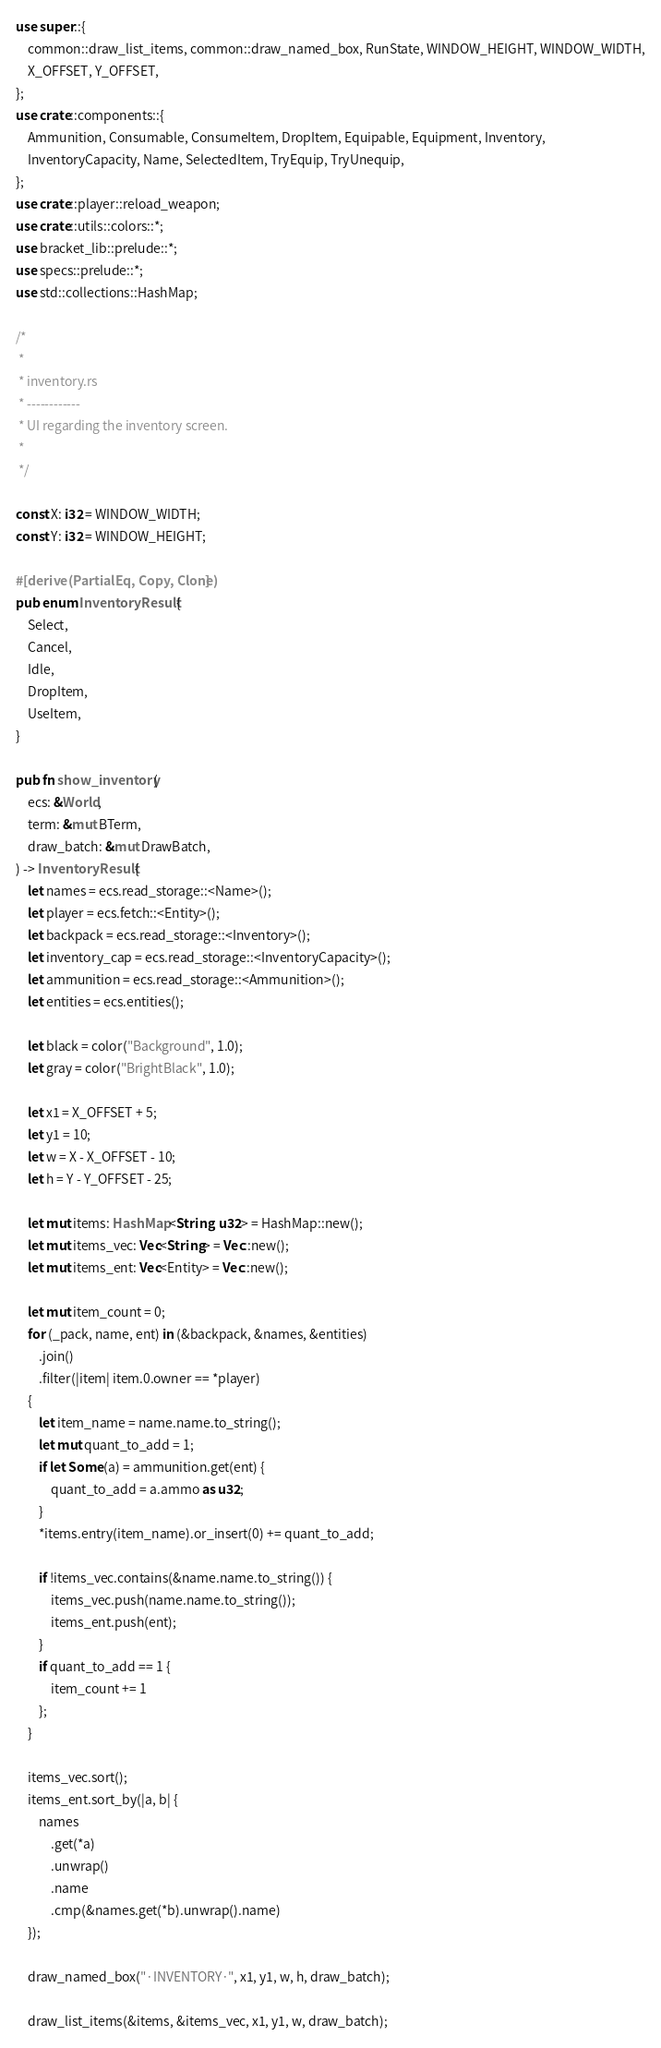<code> <loc_0><loc_0><loc_500><loc_500><_Rust_>use super::{
    common::draw_list_items, common::draw_named_box, RunState, WINDOW_HEIGHT, WINDOW_WIDTH,
    X_OFFSET, Y_OFFSET,
};
use crate::components::{
    Ammunition, Consumable, ConsumeItem, DropItem, Equipable, Equipment, Inventory,
    InventoryCapacity, Name, SelectedItem, TryEquip, TryUnequip,
};
use crate::player::reload_weapon;
use crate::utils::colors::*;
use bracket_lib::prelude::*;
use specs::prelude::*;
use std::collections::HashMap;

/*
 *
 * inventory.rs
 * ------------
 * UI regarding the inventory screen.
 *
 */

const X: i32 = WINDOW_WIDTH;
const Y: i32 = WINDOW_HEIGHT;

#[derive(PartialEq, Copy, Clone)]
pub enum InventoryResult {
    Select,
    Cancel,
    Idle,
    DropItem,
    UseItem,
}

pub fn show_inventory(
    ecs: &World,
    term: &mut BTerm,
    draw_batch: &mut DrawBatch,
) -> InventoryResult {
    let names = ecs.read_storage::<Name>();
    let player = ecs.fetch::<Entity>();
    let backpack = ecs.read_storage::<Inventory>();
    let inventory_cap = ecs.read_storage::<InventoryCapacity>();
    let ammunition = ecs.read_storage::<Ammunition>();
    let entities = ecs.entities();

    let black = color("Background", 1.0);
    let gray = color("BrightBlack", 1.0);

    let x1 = X_OFFSET + 5;
    let y1 = 10;
    let w = X - X_OFFSET - 10;
    let h = Y - Y_OFFSET - 25;

    let mut items: HashMap<String, u32> = HashMap::new();
    let mut items_vec: Vec<String> = Vec::new();
    let mut items_ent: Vec<Entity> = Vec::new();

    let mut item_count = 0;
    for (_pack, name, ent) in (&backpack, &names, &entities)
        .join()
        .filter(|item| item.0.owner == *player)
    {
        let item_name = name.name.to_string();
        let mut quant_to_add = 1;
        if let Some(a) = ammunition.get(ent) {
            quant_to_add = a.ammo as u32;
        }
        *items.entry(item_name).or_insert(0) += quant_to_add;

        if !items_vec.contains(&name.name.to_string()) {
            items_vec.push(name.name.to_string());
            items_ent.push(ent);
        }
        if quant_to_add == 1 {
            item_count += 1
        };
    }

    items_vec.sort();
    items_ent.sort_by(|a, b| {
        names
            .get(*a)
            .unwrap()
            .name
            .cmp(&names.get(*b).unwrap().name)
    });

    draw_named_box("·INVENTORY·", x1, y1, w, h, draw_batch);

    draw_list_items(&items, &items_vec, x1, y1, w, draw_batch);
</code> 